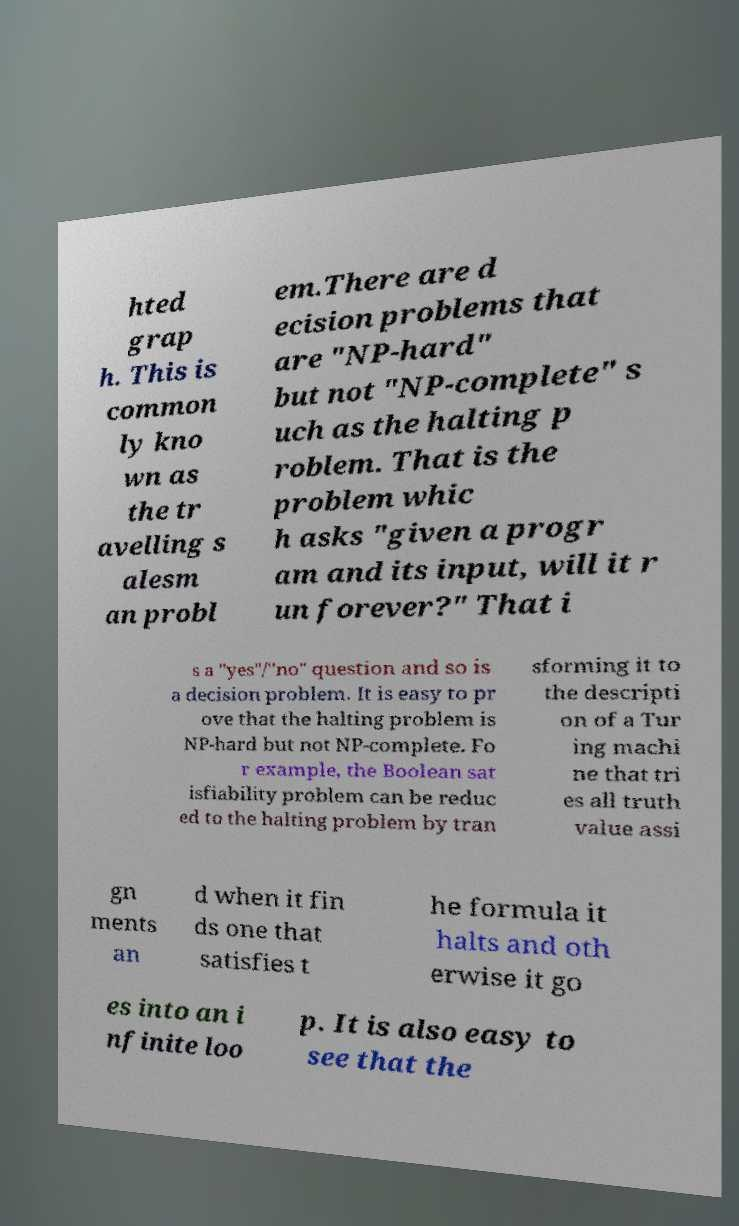I need the written content from this picture converted into text. Can you do that? hted grap h. This is common ly kno wn as the tr avelling s alesm an probl em.There are d ecision problems that are "NP-hard" but not "NP-complete" s uch as the halting p roblem. That is the problem whic h asks "given a progr am and its input, will it r un forever?" That i s a "yes"/"no" question and so is a decision problem. It is easy to pr ove that the halting problem is NP-hard but not NP-complete. Fo r example, the Boolean sat isfiability problem can be reduc ed to the halting problem by tran sforming it to the descripti on of a Tur ing machi ne that tri es all truth value assi gn ments an d when it fin ds one that satisfies t he formula it halts and oth erwise it go es into an i nfinite loo p. It is also easy to see that the 